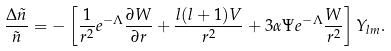<formula> <loc_0><loc_0><loc_500><loc_500>\frac { \Delta \tilde { n } } { \tilde { n } } = - \left [ \frac { 1 } { r ^ { 2 } } e ^ { - \Lambda } \frac { \partial W } { \partial r } + \frac { l ( l + 1 ) V } { r ^ { 2 } } + 3 \alpha \Psi e ^ { - \Lambda } \frac { W } { r ^ { 2 } } \right ] Y _ { l m } .</formula> 